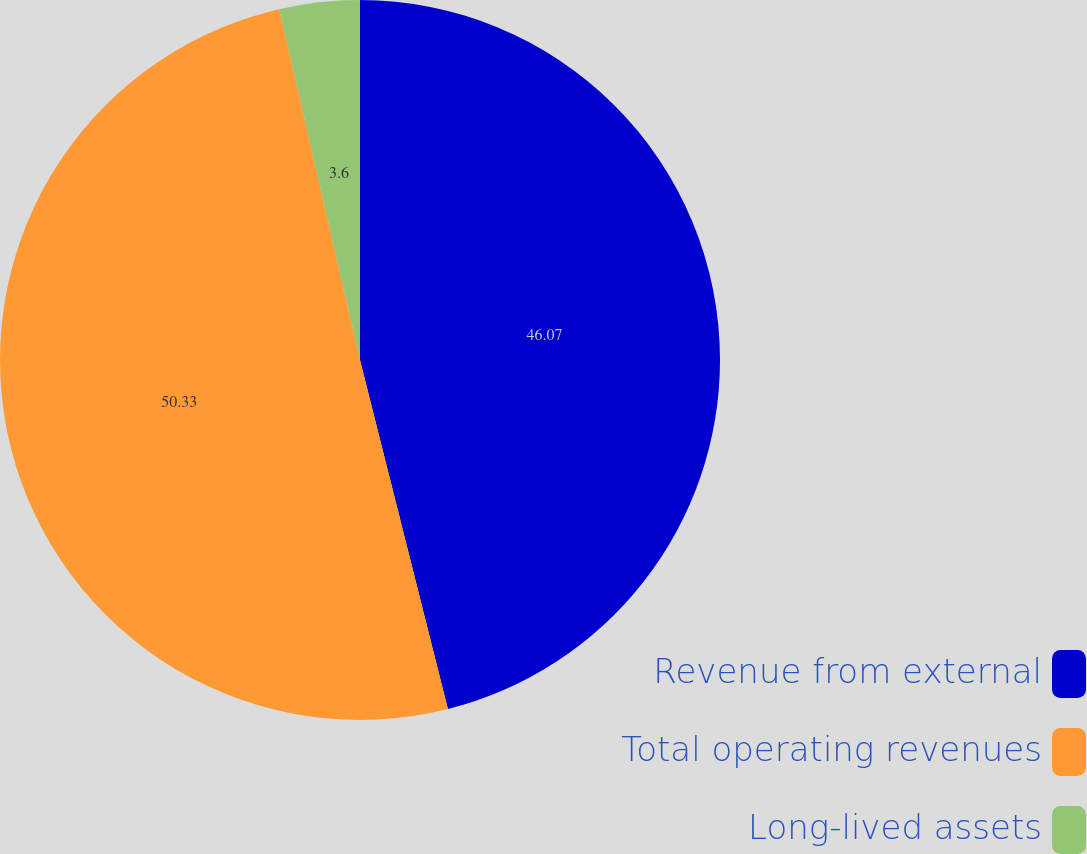Convert chart. <chart><loc_0><loc_0><loc_500><loc_500><pie_chart><fcel>Revenue from external<fcel>Total operating revenues<fcel>Long-lived assets<nl><fcel>46.07%<fcel>50.32%<fcel>3.6%<nl></chart> 